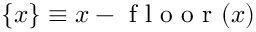<formula> <loc_0><loc_0><loc_500><loc_500>\{ x \} \equiv x - f l o o r ( x )</formula> 